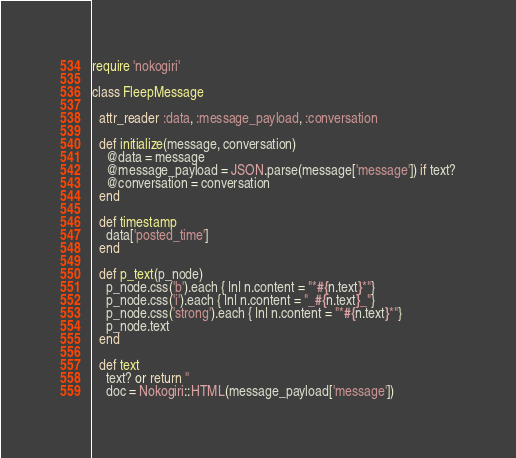Convert code to text. <code><loc_0><loc_0><loc_500><loc_500><_Ruby_>require 'nokogiri'

class FleepMessage

  attr_reader :data, :message_payload, :conversation

  def initialize(message, conversation)
    @data = message
    @message_payload = JSON.parse(message['message']) if text?
    @conversation = conversation
  end

  def timestamp
    data['posted_time']
  end

  def p_text(p_node)
    p_node.css('b').each { |n| n.content = "*#{n.text}*"}
    p_node.css('i').each { |n| n.content = "_#{n.text}_"}
    p_node.css('strong').each { |n| n.content = "*#{n.text}*"}
    p_node.text
  end

  def text
    text? or return ''
    doc = Nokogiri::HTML(message_payload['message'])</code> 